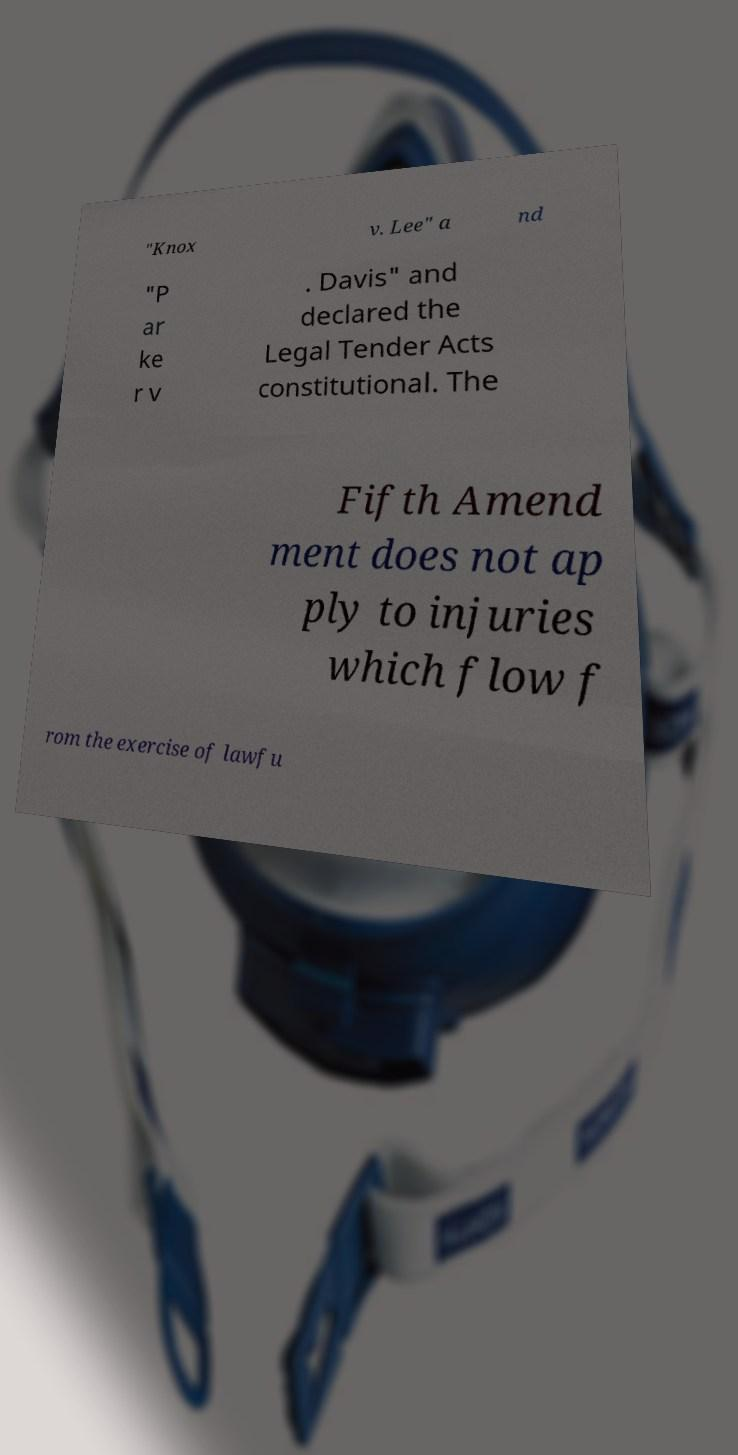Could you assist in decoding the text presented in this image and type it out clearly? "Knox v. Lee" a nd "P ar ke r v . Davis" and declared the Legal Tender Acts constitutional. The Fifth Amend ment does not ap ply to injuries which flow f rom the exercise of lawfu 